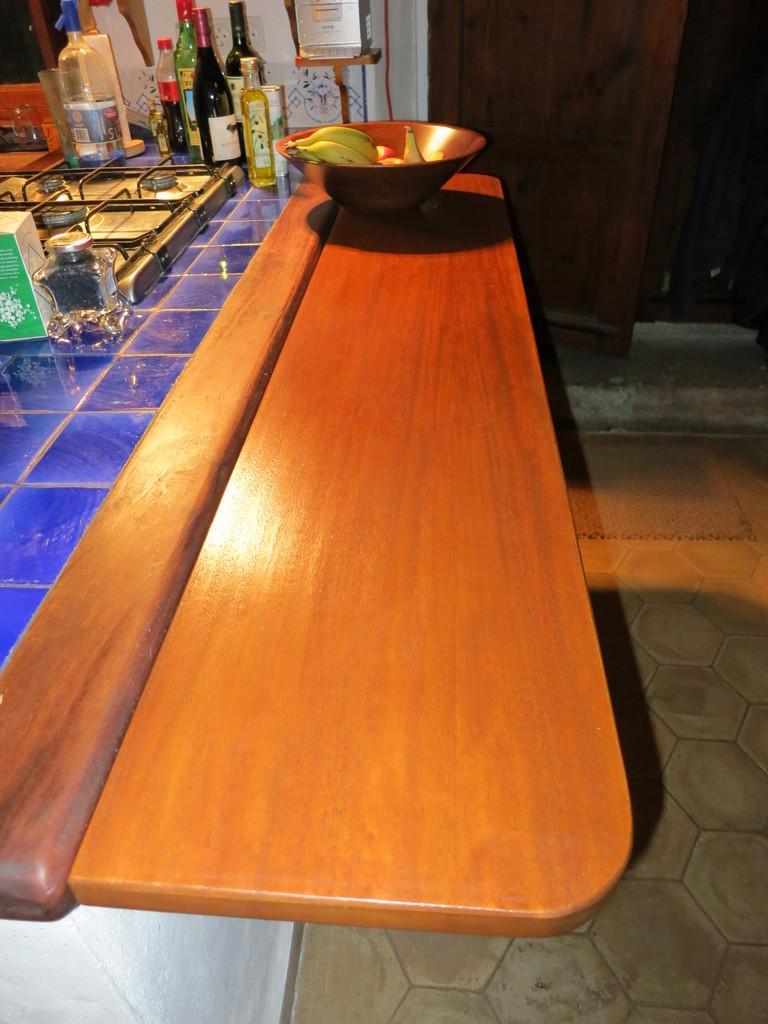Describe this image in one or two sentences. This picture shows a wooden countertop and we see a gas stove,few wine bottles and a bowl with some fruits 